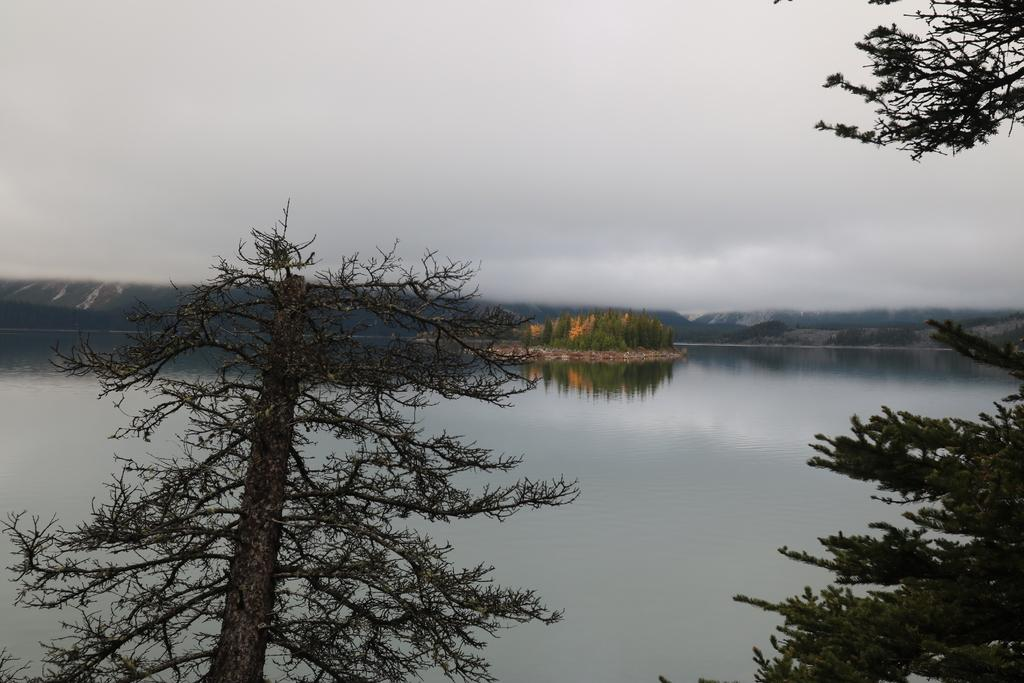What is the primary element visible in the image? There is water in the image. What type of vegetation can be seen in the image? There are trees in the image. What can be seen in the distance in the image? There are hills visible in the background of the image. What is visible in the sky in the image? The sky is visible in the background of the image, and clouds are present. What type of business is being conducted in the image? There is no indication of any business activity in the image. How many competitors are visible in the image? There are no competitors present in the image. 